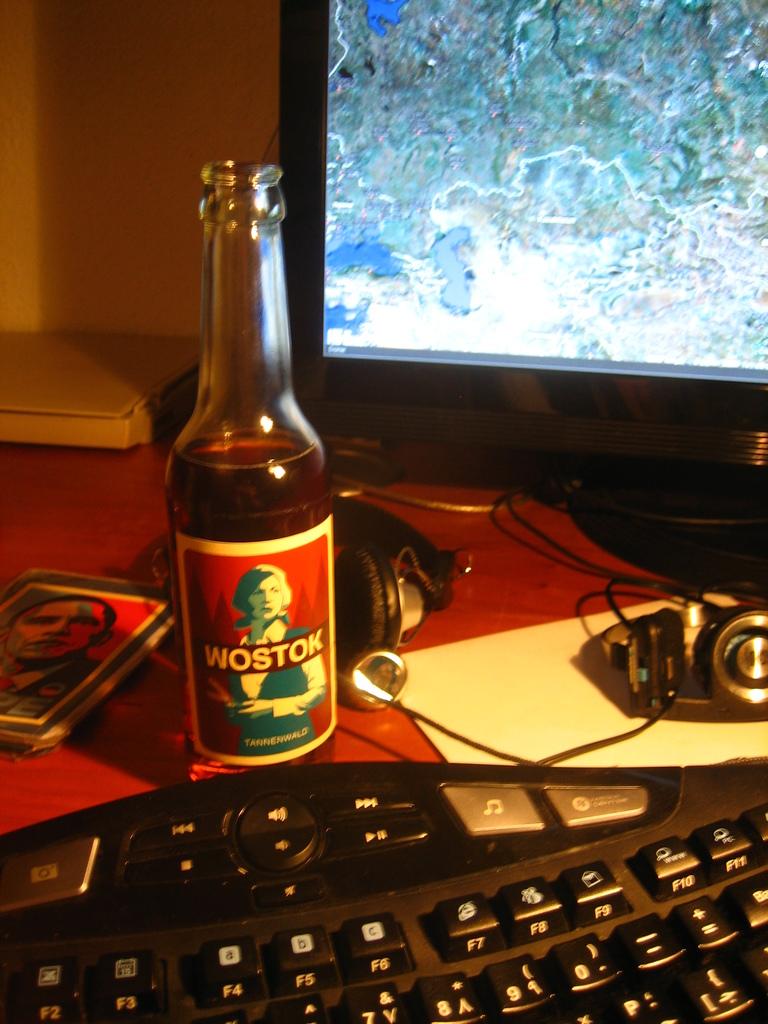What drink is that?
Offer a terse response. Wostok. What letter is shown on the f4 key?
Give a very brief answer. A. 